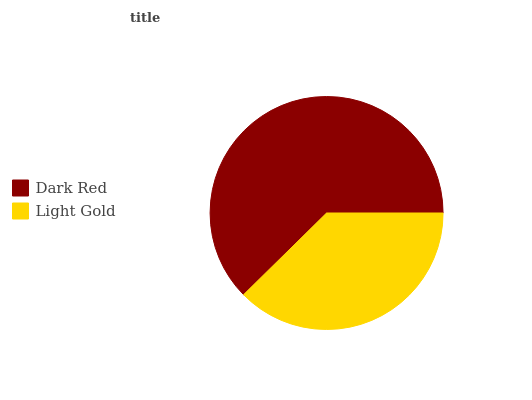Is Light Gold the minimum?
Answer yes or no. Yes. Is Dark Red the maximum?
Answer yes or no. Yes. Is Light Gold the maximum?
Answer yes or no. No. Is Dark Red greater than Light Gold?
Answer yes or no. Yes. Is Light Gold less than Dark Red?
Answer yes or no. Yes. Is Light Gold greater than Dark Red?
Answer yes or no. No. Is Dark Red less than Light Gold?
Answer yes or no. No. Is Dark Red the high median?
Answer yes or no. Yes. Is Light Gold the low median?
Answer yes or no. Yes. Is Light Gold the high median?
Answer yes or no. No. Is Dark Red the low median?
Answer yes or no. No. 